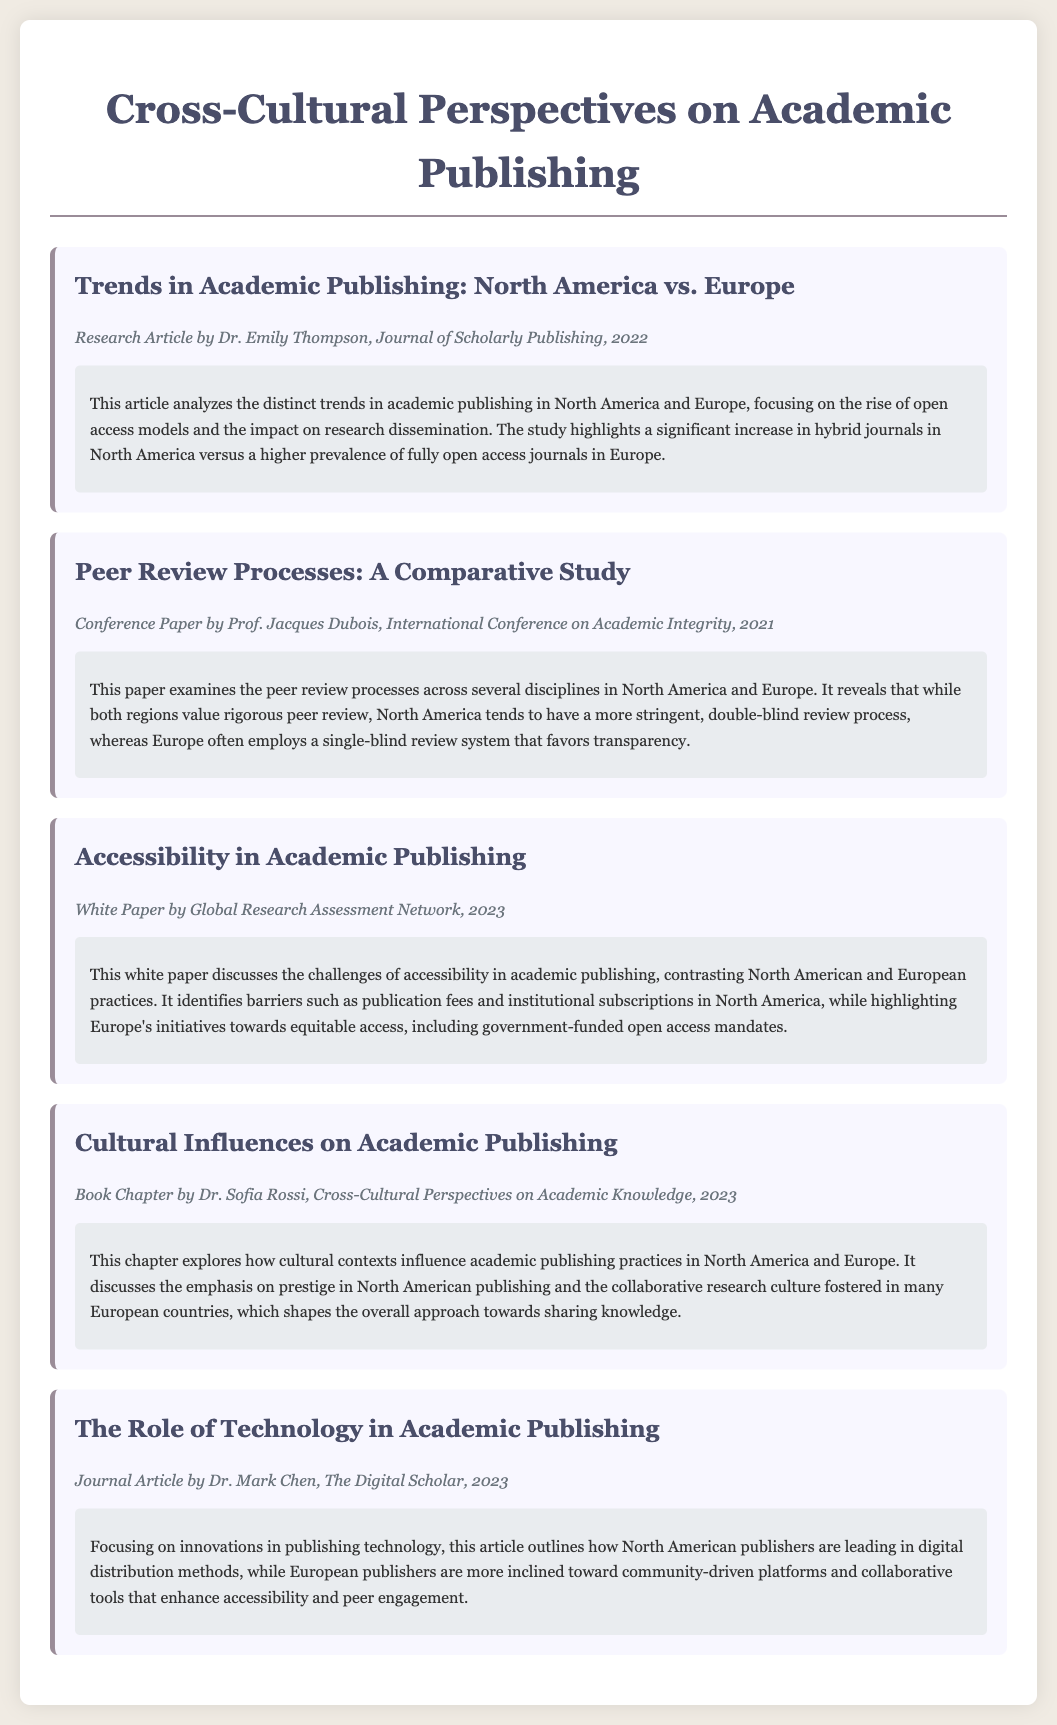What is the title of the first article? The title of the first article is listed in the catalog as given under the first catalog item.
Answer: Trends in Academic Publishing: North America vs. Europe Who authored the paper on peer review processes? The author of the peer review processes paper is mentioned directly in the meta section of the document.
Answer: Prof. Jacques Dubois In what year was the white paper on accessibility published? The publication year of the white paper is explicitly stated in the metadata of the catalog item.
Answer: 2023 What type of publishing model is seeing a significant increase in North America? The document mentions a specific trend related to publishing models in North America.
Answer: Hybrid journals Which review process is more commonly used in North America? The document specifies which type of peer review process is prevalent in North America when discussing the differences.
Answer: Double-blind review What cultural aspect does Dr. Sofia Rossi’s chapter explore? The document clearly states the focus of Dr. Sofia Rossi's chapter as outlined in the summary section.
Answer: Cultural contexts How do European journals primarily differ in their peer review process from North American journals? The document contrasts the peer review processes, detailing the differences in practice between the two regions.
Answer: Single-blind review What is the focus of Dr. Mark Chen's article? The focus of Dr. Mark Chen's article is described in the title and summary of the article in the catalog.
Answer: Innovations in publishing technology 